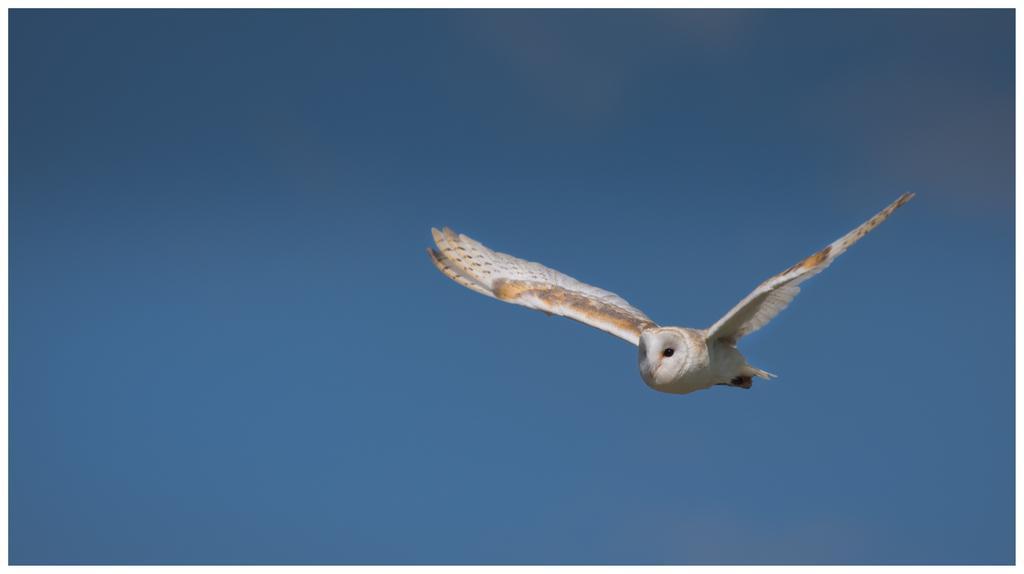How would you summarize this image in a sentence or two? As we can see in the image there is a bird and sky. 